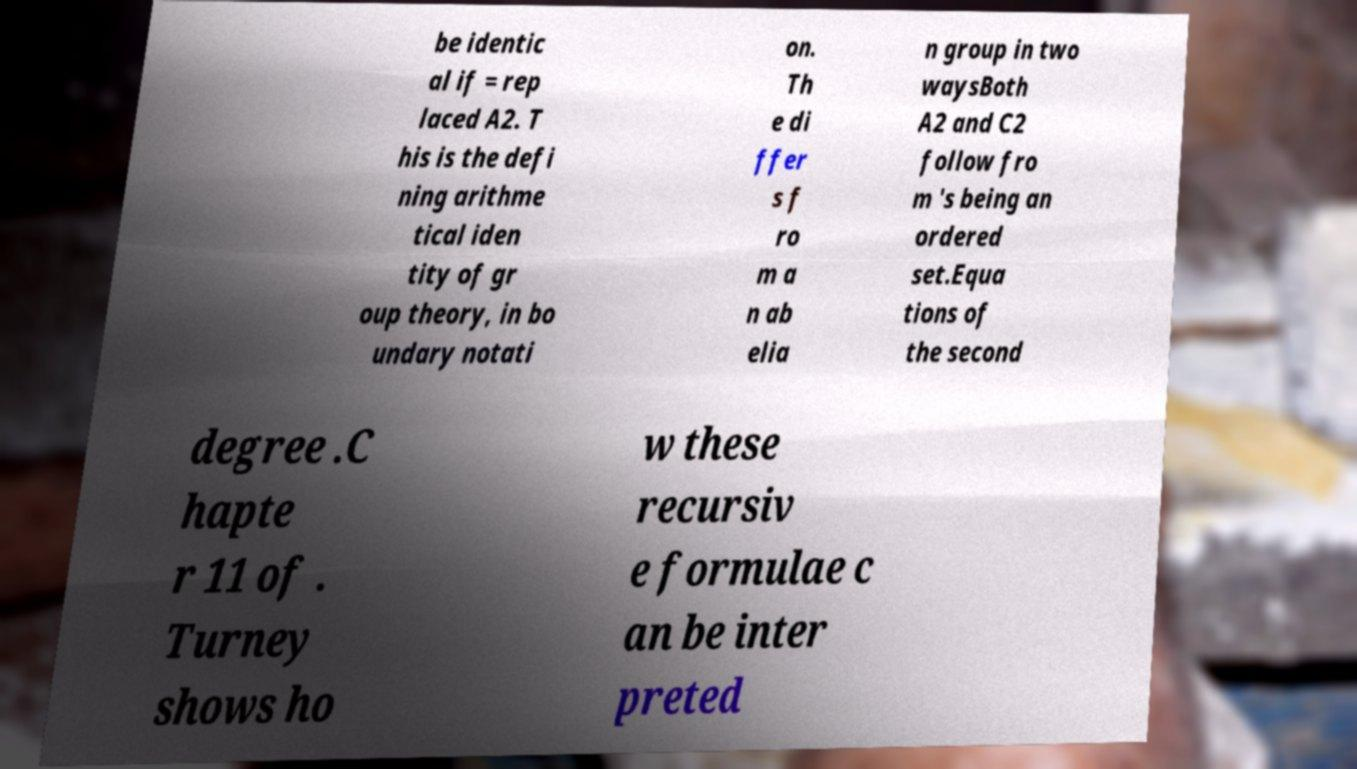For documentation purposes, I need the text within this image transcribed. Could you provide that? be identic al if = rep laced A2. T his is the defi ning arithme tical iden tity of gr oup theory, in bo undary notati on. Th e di ffer s f ro m a n ab elia n group in two waysBoth A2 and C2 follow fro m 's being an ordered set.Equa tions of the second degree .C hapte r 11 of . Turney shows ho w these recursiv e formulae c an be inter preted 